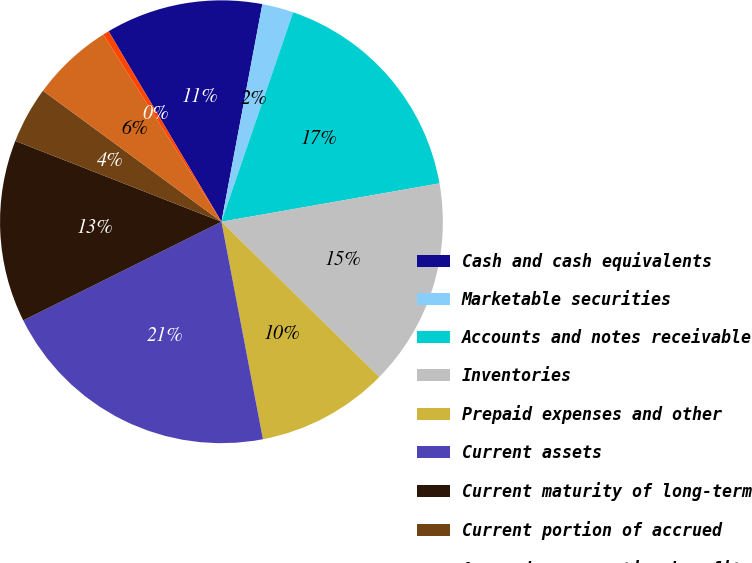Convert chart to OTSL. <chart><loc_0><loc_0><loc_500><loc_500><pie_chart><fcel>Cash and cash equivalents<fcel>Marketable securities<fcel>Accounts and notes receivable<fcel>Inventories<fcel>Prepaid expenses and other<fcel>Current assets<fcel>Current maturity of long-term<fcel>Current portion of accrued<fcel>Accrued compensation benefits<fcel>Taxes payable (including taxes<nl><fcel>11.47%<fcel>2.29%<fcel>16.98%<fcel>15.14%<fcel>9.63%<fcel>20.65%<fcel>13.3%<fcel>4.13%<fcel>5.96%<fcel>0.45%<nl></chart> 